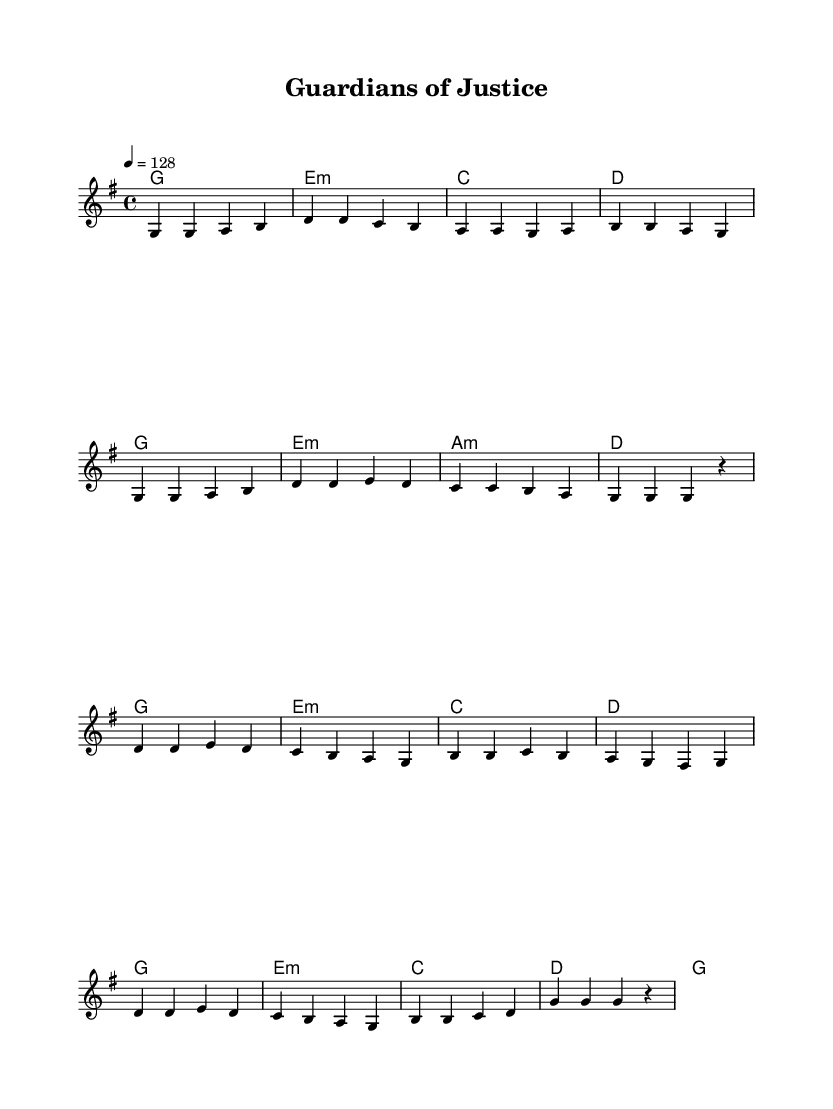What is the key signature of this music? The key signature is G major, which includes one sharp (F#). This can be identified at the beginning of the sheet music, just after the clef symbol.
Answer: G major What is the time signature of this music? The time signature is 4/4, which means there are four beats per measure. This is indicated at the start of the sheet music, next to the key signature.
Answer: 4/4 What is the tempo marking of this music? The tempo marking indicates 128 beats per minute, specified as "4 = 128". This shows the pace at which the music should be played.
Answer: 128 How many measures are in the verse section? The verse section consists of 8 measures, as counted from the start of the melody line until the transition to the chorus. Each grouping of notes separated by vertical lines represents a measure.
Answer: 8 What are the primary chords used in the verse section? The primary chords are G, E minor, C, and D. These chords correspond to the harmonic progression shown underneath the melody for the verse section.
Answer: G, E minor, C, D What theme does the music focus on, based on its title? The title "Guardians of Justice" suggests a theme related to law enforcement and justice, reflecting the ideals and imagery often associated with K-Pop songs about these topics.
Answer: Law enforcement and justice How would you categorize the music style of this piece? This piece can be categorized as upbeat K-Pop, as indicated by the tempo, lively melody, and structure of the song, typical of the K-Pop genre which often has energetic and positive themes.
Answer: Upbeat K-Pop 